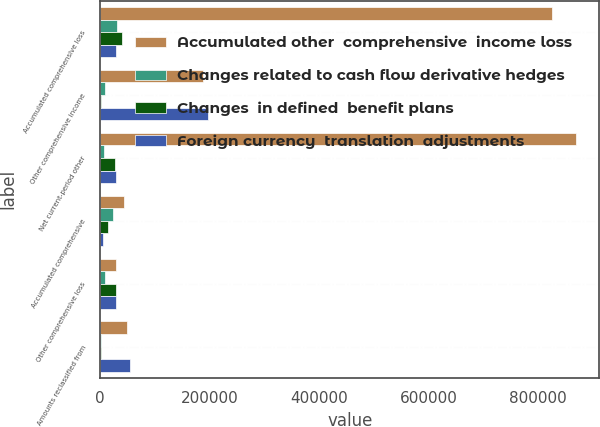Convert chart. <chart><loc_0><loc_0><loc_500><loc_500><stacked_bar_chart><ecel><fcel>Accumulated comprehensive loss<fcel>Other comprehensive income<fcel>Net current-period other<fcel>Accumulated comprehensive<fcel>Other comprehensive loss<fcel>Amounts reclassified from<nl><fcel>Accumulated other  comprehensive  income loss<fcel>826026<fcel>188073<fcel>869350<fcel>43324<fcel>29653<fcel>49744<nl><fcel>Changes related to cash flow derivative hedges<fcel>31207<fcel>8240<fcel>7213<fcel>23994<fcel>8937<fcel>1724<nl><fcel>Changes  in defined  benefit plans<fcel>39761<fcel>1529<fcel>26102<fcel>13659<fcel>28099<fcel>1997<nl><fcel>Foreign currency  translation  adjustments<fcel>29653<fcel>197842<fcel>29653<fcel>5671<fcel>29653<fcel>53465<nl></chart> 